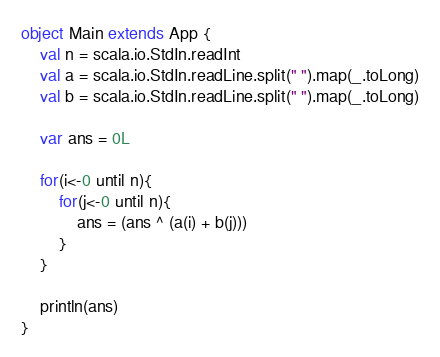<code> <loc_0><loc_0><loc_500><loc_500><_Scala_>object Main extends App {
	val n = scala.io.StdIn.readInt
	val a = scala.io.StdIn.readLine.split(" ").map(_.toLong)
	val b = scala.io.StdIn.readLine.split(" ").map(_.toLong)

	var ans = 0L

	for(i<-0 until n){
		for(j<-0 until n){
			ans = (ans ^ (a(i) + b(j)))
		}
	}

	println(ans)
}</code> 